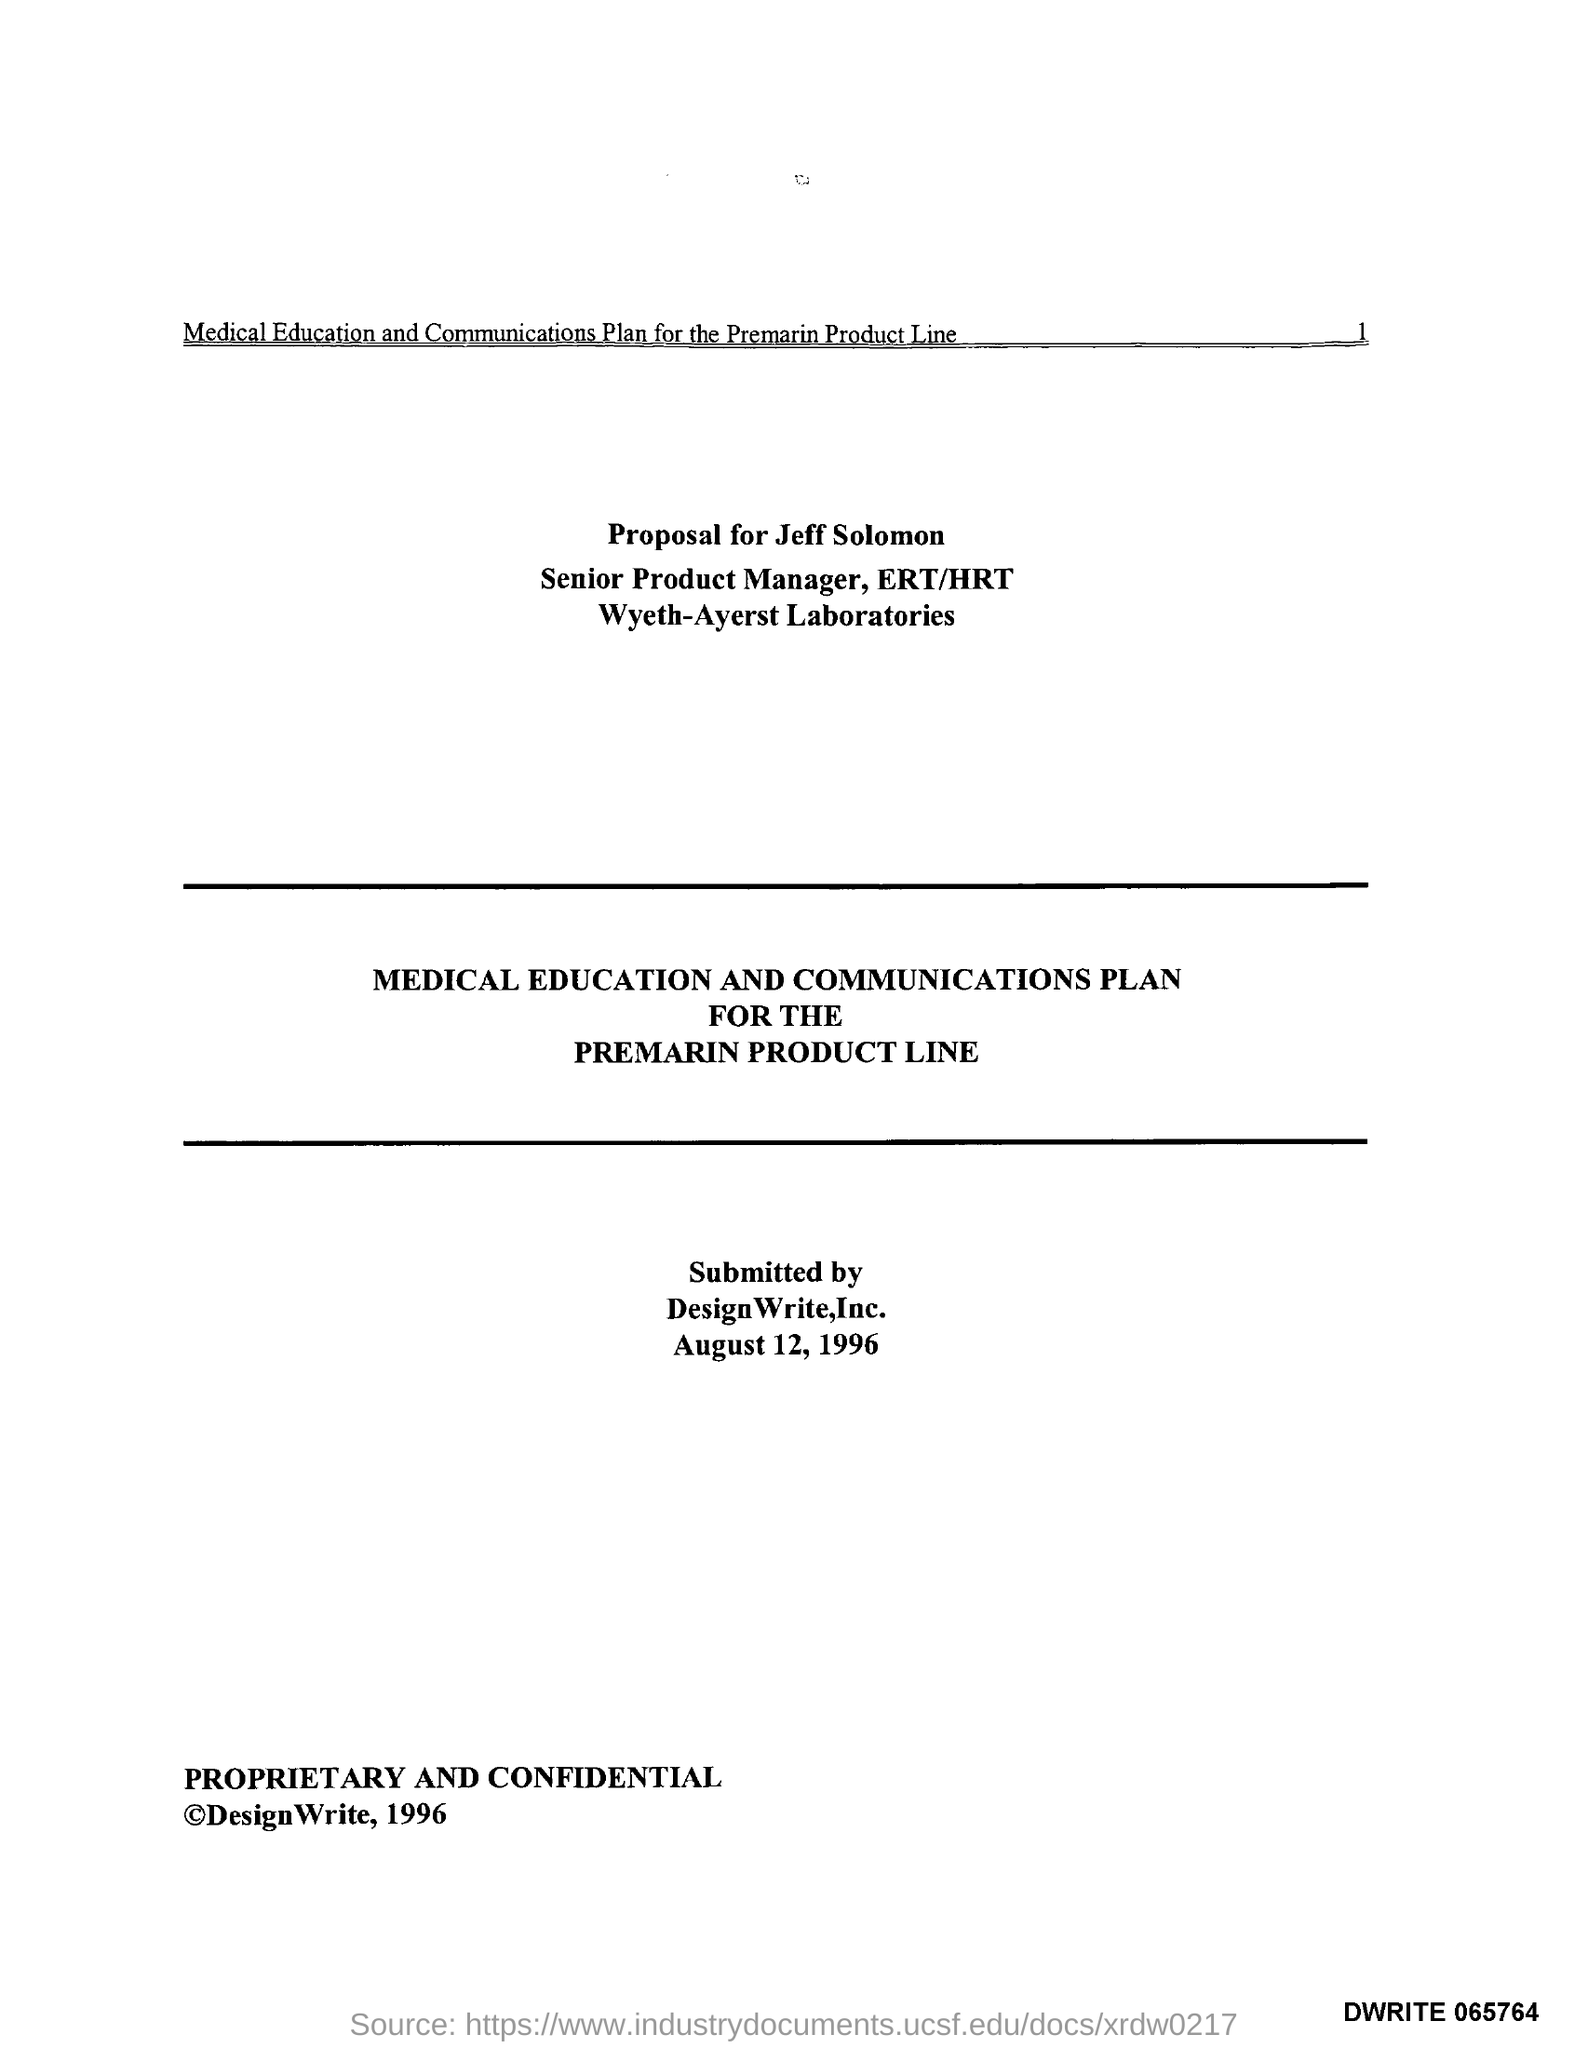Identify some key points in this picture. The submission was made on August 12, 1996. The submission was made by DesignWrite, Inc. 